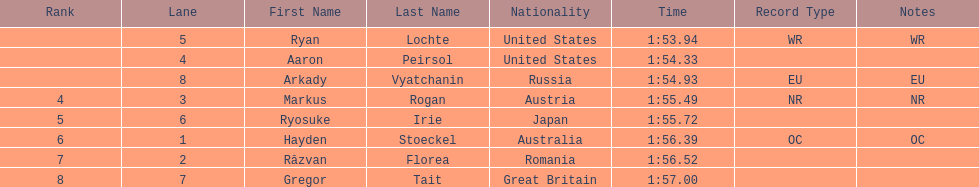How many swimmers finished in less than 1:55? 3. 